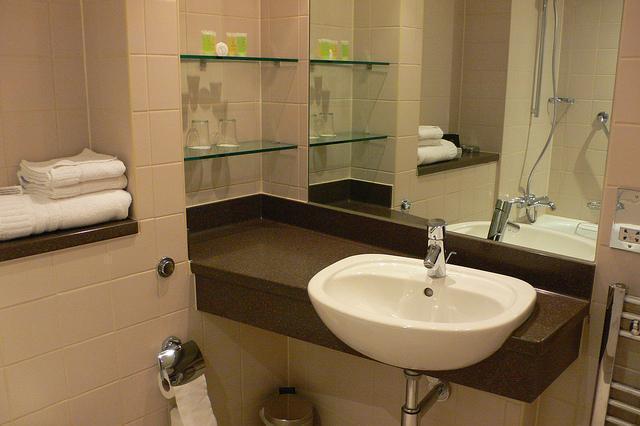What happens if you pull the lever in the middle of the photo?
Select the accurate response from the four choices given to answer the question.
Options: Nothing, water comes, soda comes, air comes. Water comes. 